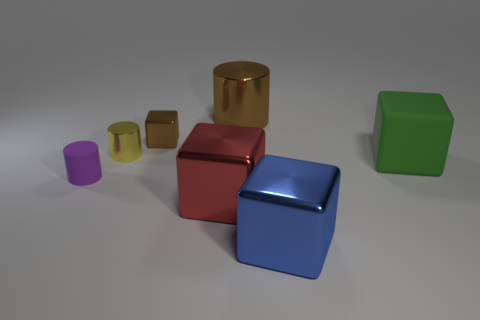There is a thing that is the same color as the tiny block; what size is it?
Your answer should be compact. Large. Do the brown shiny object right of the big red thing and the large green thing have the same shape?
Your answer should be very brief. No. Are there more tiny yellow shiny cylinders to the right of the brown cylinder than yellow shiny objects that are to the right of the yellow metallic thing?
Offer a terse response. No. How many green matte cubes are behind the rubber thing right of the red cube?
Give a very brief answer. 0. What material is the thing that is the same color as the tiny metallic cube?
Provide a succinct answer. Metal. What number of other objects are the same color as the big cylinder?
Your answer should be very brief. 1. What color is the big metallic object that is behind the matte object that is on the right side of the tiny purple rubber cylinder?
Make the answer very short. Brown. Is there another cube of the same color as the small metal block?
Offer a terse response. No. Is the number of small cyan rubber balls the same as the number of things?
Keep it short and to the point. No. How many metallic things are either small gray blocks or large brown cylinders?
Offer a very short reply. 1. 